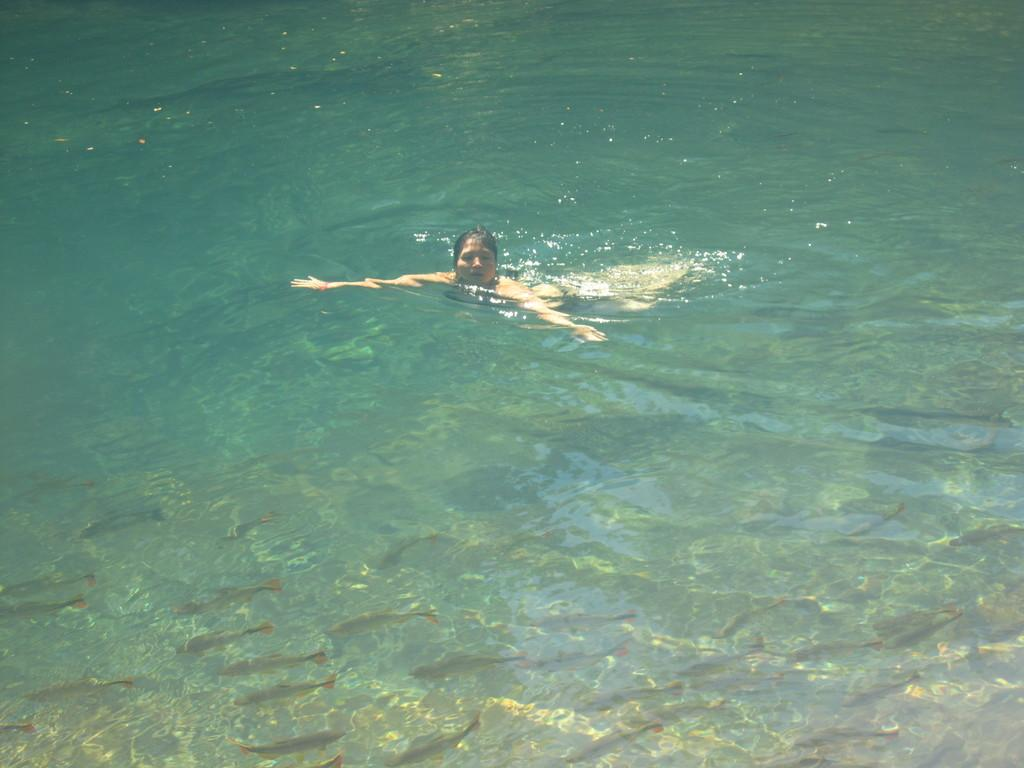Who is the main subject in the image? There is a woman in the image. What is the woman doing in the image? The woman is swimming in the water. What type of silk clothing is the woman wearing while swimming in the image? There is no mention of silk clothing in the image, and the woman's attire is not visible. 